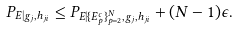Convert formula to latex. <formula><loc_0><loc_0><loc_500><loc_500>P _ { E | g _ { j } , h _ { j i } } & \leq P _ { E | \{ E _ { p } ^ { c } \} _ { p = 2 } ^ { N } , g _ { j } , h _ { j i } } + ( N - 1 ) \epsilon .</formula> 